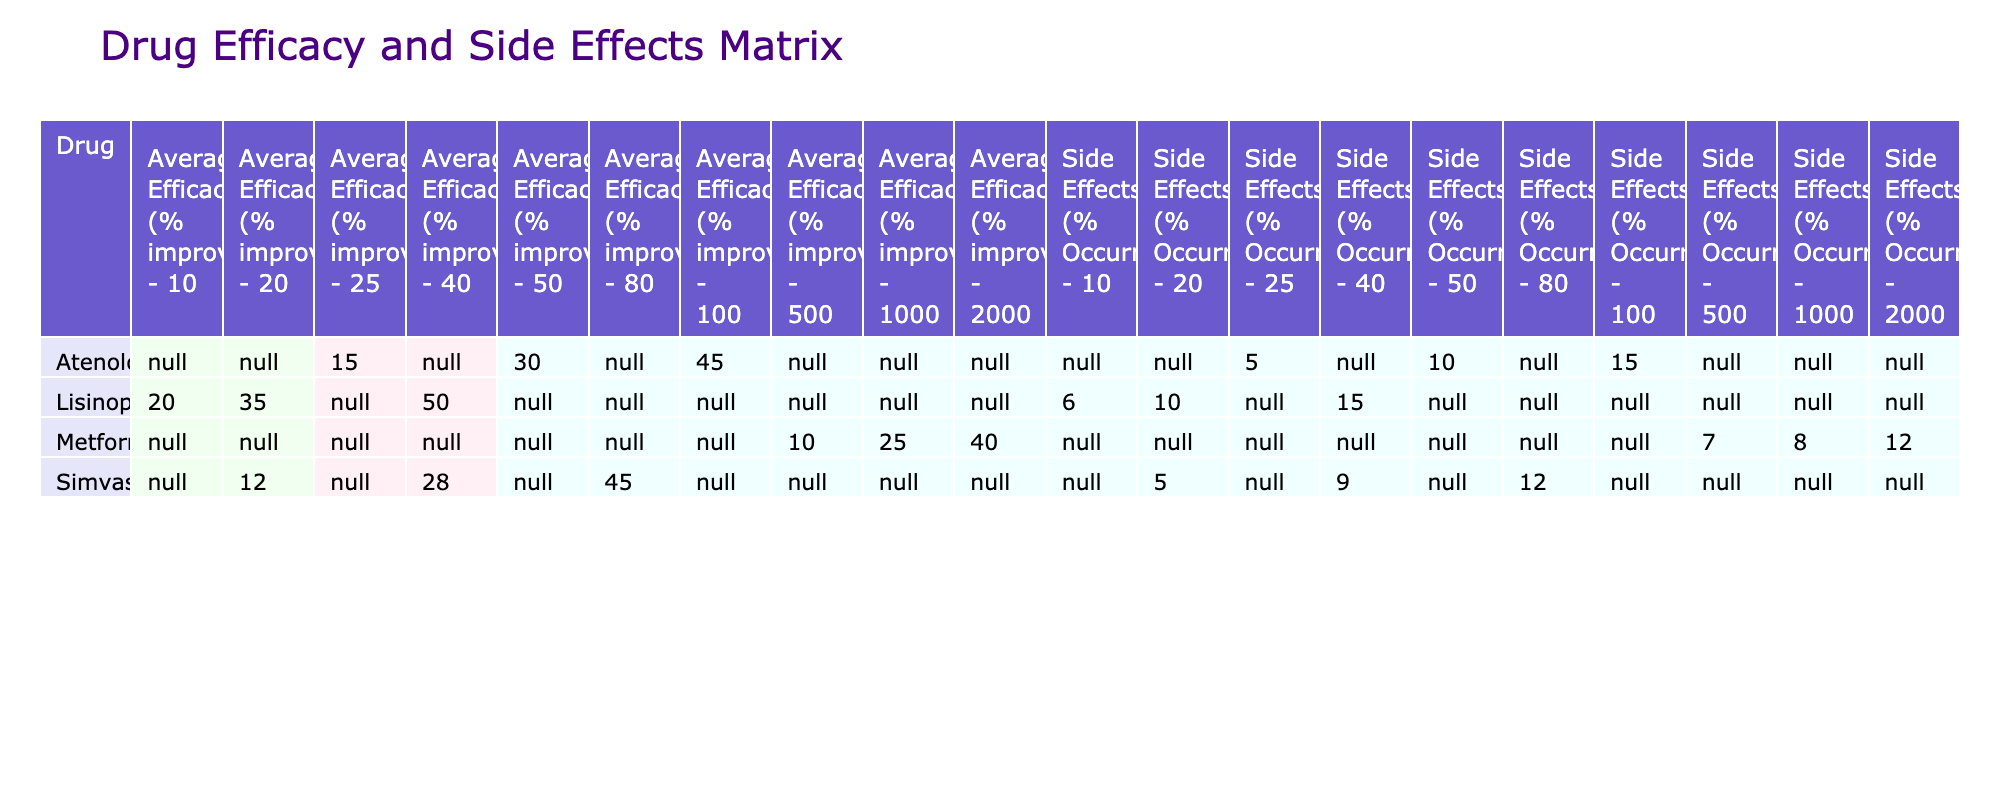What is the maximum averaged efficacy recorded for Atenolol? The table shows the averaged efficacy for Atenolol at different dosages. The highest efficacy is at 100 mg, where it is recorded as 45% improvement.
Answer: 45% improvement What is the side effects occurrence percentage for the lowest dosage of Lisinopril? Looking at the Lisinopril row in the table, the lowest dosage listed is 10 mg, which has a side effects occurrence of 6%.
Answer: 6% Which drug has the highest side effects occurrence percentage? To find this, we compare the side effects percentage for all drugs listed. Simvastatin at 80 mg has the highest occurrence at 12%.
Answer: 12% What is the average efficacy for Metformin across all dosages? To compute the average, we take the efficacy values for Metformin: 10%, 25%, and 40%, sum them up (10 + 25 + 40 = 75) and divide by the number of dosages (3), giving us 75 / 3 = 25%.
Answer: 25% Did Group C have a higher average efficacy than Group B? We can calculate the average efficacy for both groups. Group C has efficacy values of 20%, 35%, and 50%, summing them gives 105%, and dividing by 3 gives an average of 35%. Group B has values of 10%, 25%, and 40%, summing them gives 75% and dividing by 3 gives 25%. Since 35% (Group C) is greater than 25% (Group B), the statement is true.
Answer: Yes What is the side effects occurrence for Metformin at the highest dosage? In the table, for Metformin at the highest dosage of 2000 mg, the side effects occurrence listed is 12%.
Answer: 12% Which drug had the highest efficacy improvement at its lowest dosage? Looking at the lowest dosages, Atenolol at 25 mg has a 15% improvement, Lisinopril at 10 mg is 20%, Metformin at 500 mg is 10%, and Simvastatin at 20 mg is 12%. The highest is Lisinopril with 20%.
Answer: Lisinopril What is the average duration of trials for Drug A and Drug C? Atenolol (Drug A) has a trial duration of 12 weeks, and Lisinopril (Drug C) has a duration of 16 weeks. The average is (12 + 16) / 2 = 14 weeks.
Answer: 14 weeks 